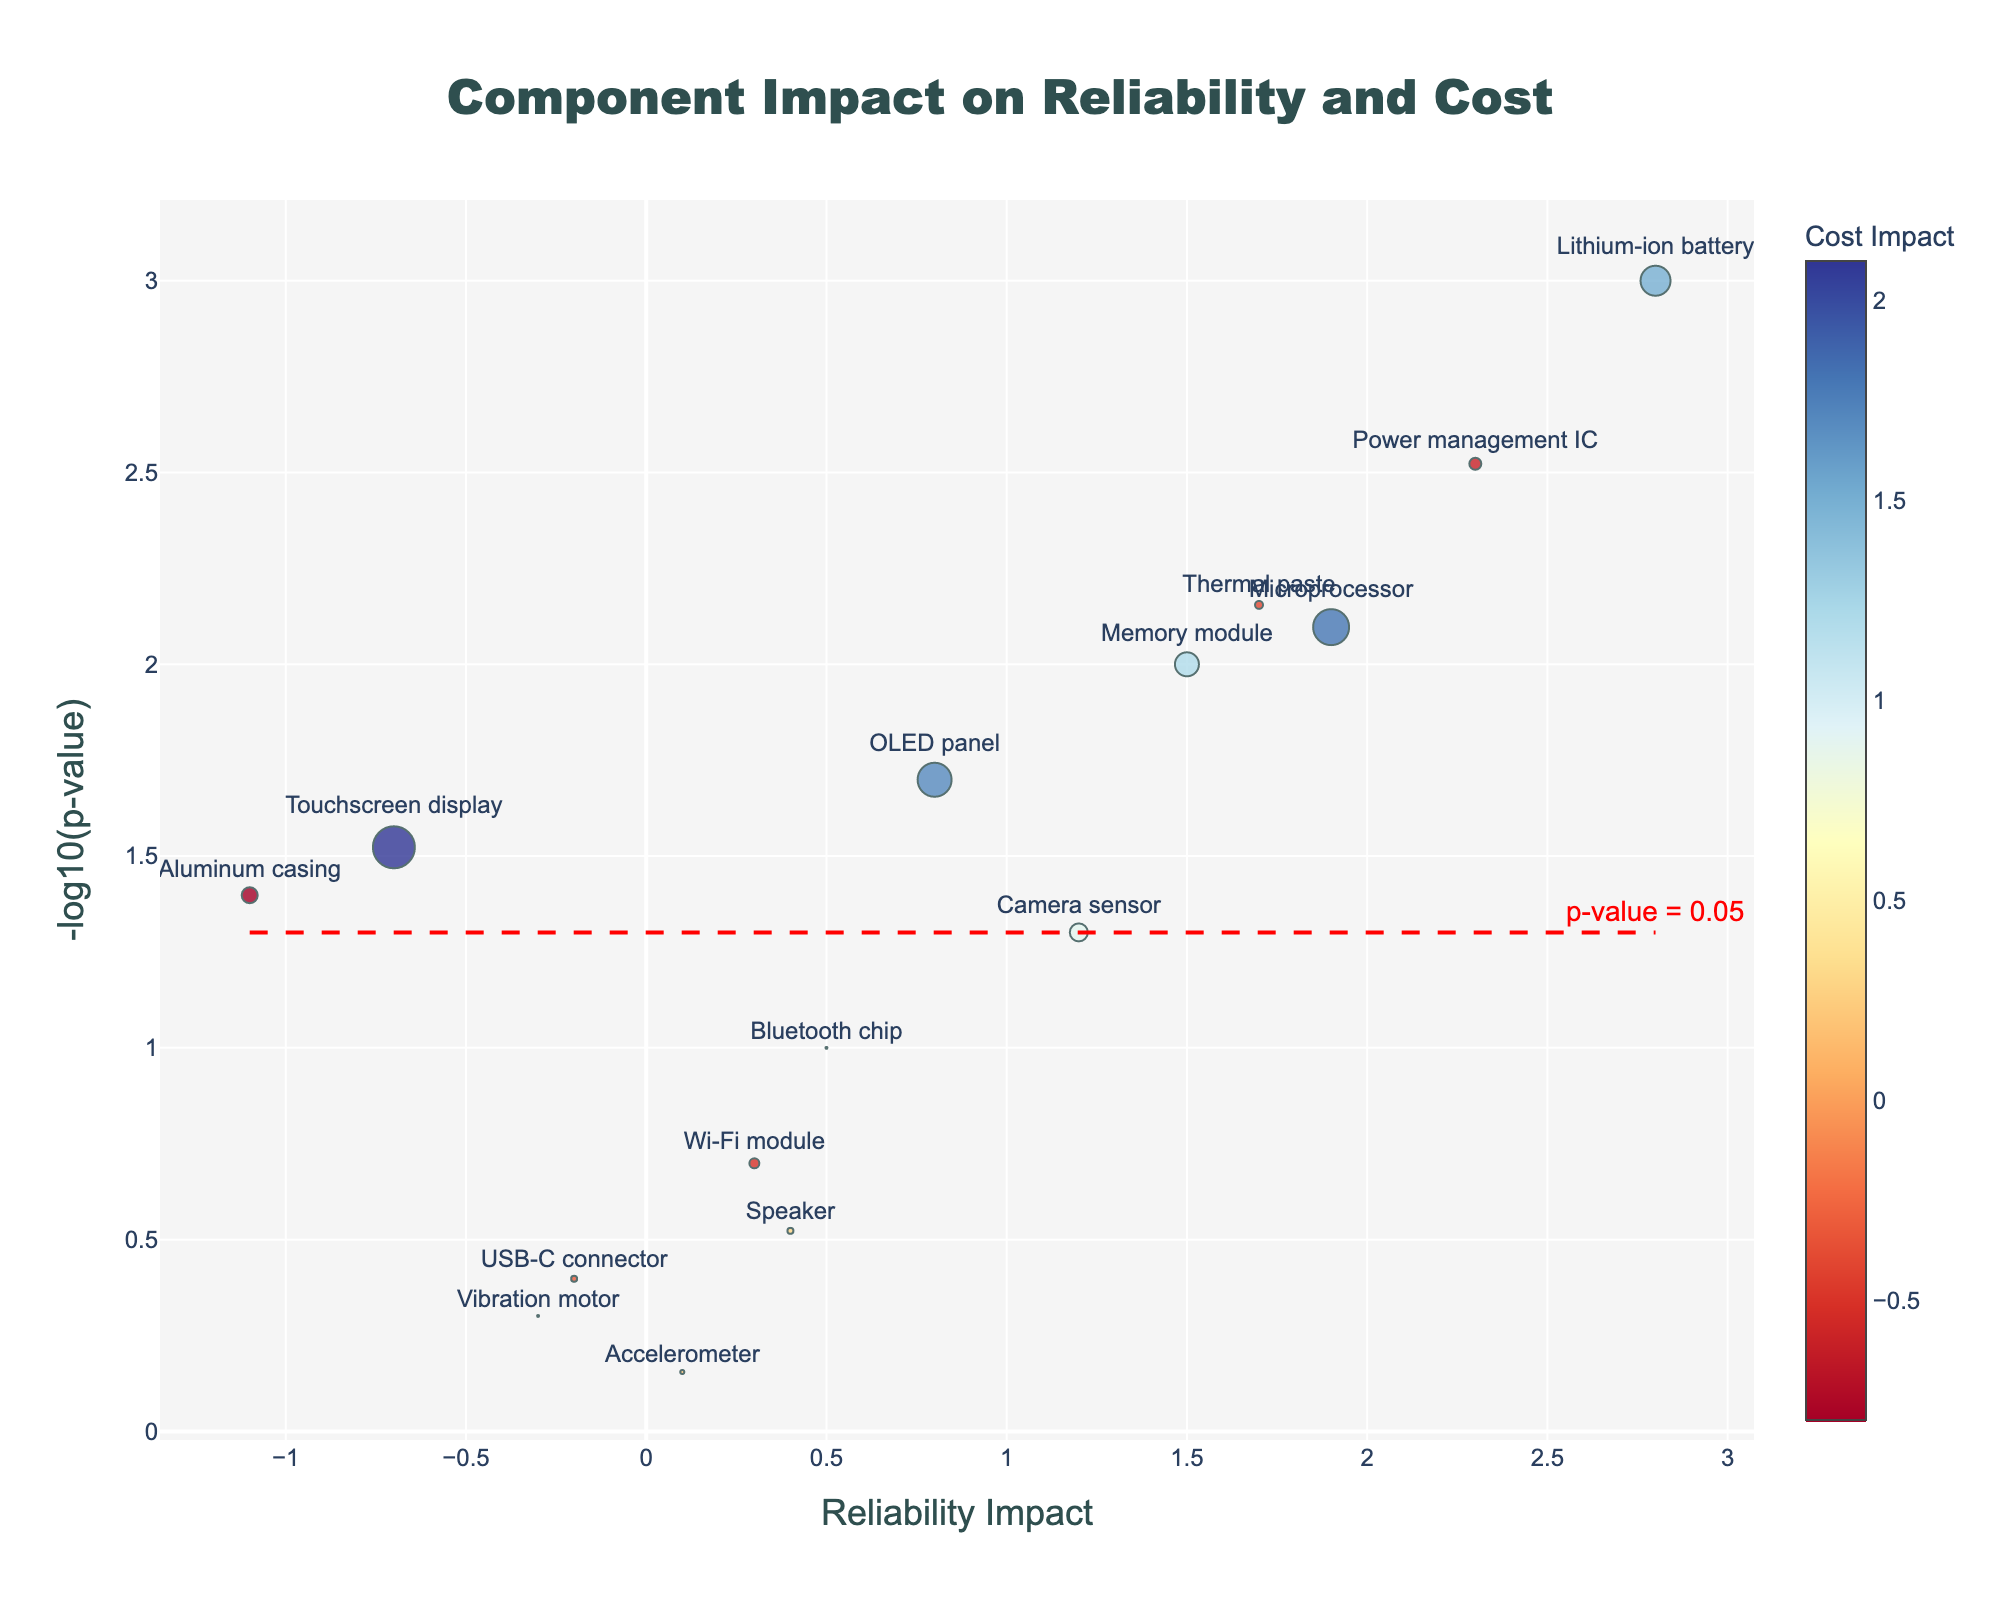How many components are labeled in the figure? Count the number of labels visible next to the markers in the figure.
Answer: 14 Which component has the highest reliability impact? Look for the component positioned the furthest to the right on the x-axis labeled "Reliability Impact."
Answer: Lithium-ion battery What is the reliability impact of the Wi-Fi module? Identify the marker labeled "Wi-Fi module" and check its position on the x-axis.
Answer: 0.3 Which component has the lowest p-value and what is its cost impact? Identify the marker with the highest -log10(p-value) on the y-axis, as it represents the lowest p-value. Then, note its cost impact color or hover text.
Answer: Lithium-ion battery; 1.5 How many components have a significant p-value (p < 0.05)? Count the number of components positioned above the horizontal red dashed line representing the threshold of -log10(0.05).
Answer: 8 Which component has the most negative reliability impact, and what is its -log10(p-value)? Look for the component furthest to the left on the x-axis and note its position on the y-axis (height).
Answer: Aluminum casing; 1.40 Compare the cost impact between the Microprocessor and the Memory module. Which one is higher? Identify the markers for "Microprocessor" and "Memory module" and compare their respective colors, which indicate cost impact according to the color scale.
Answer: Microprocessor Is there any component that has a negative cost impact but a significant p-value? Look for markers positioned above the red dashed line (significant p-value) and check their color on the negative side of the color scale.
Answer: Yes, the Power management IC and Thermal paste What does the horizontal red dashed line represent in the figure? The horizontal red dashed line is placed at -log10(0.05) and indicates the threshold for statistical significance of the p-value.
Answer: p-value = 0.05 Which component affects reliability the most but has the least cost impact? Look for the component with the highest reliability impact value and then check its cost impact which should be lowest.
Answer: Lithium-ion battery; 1.5 